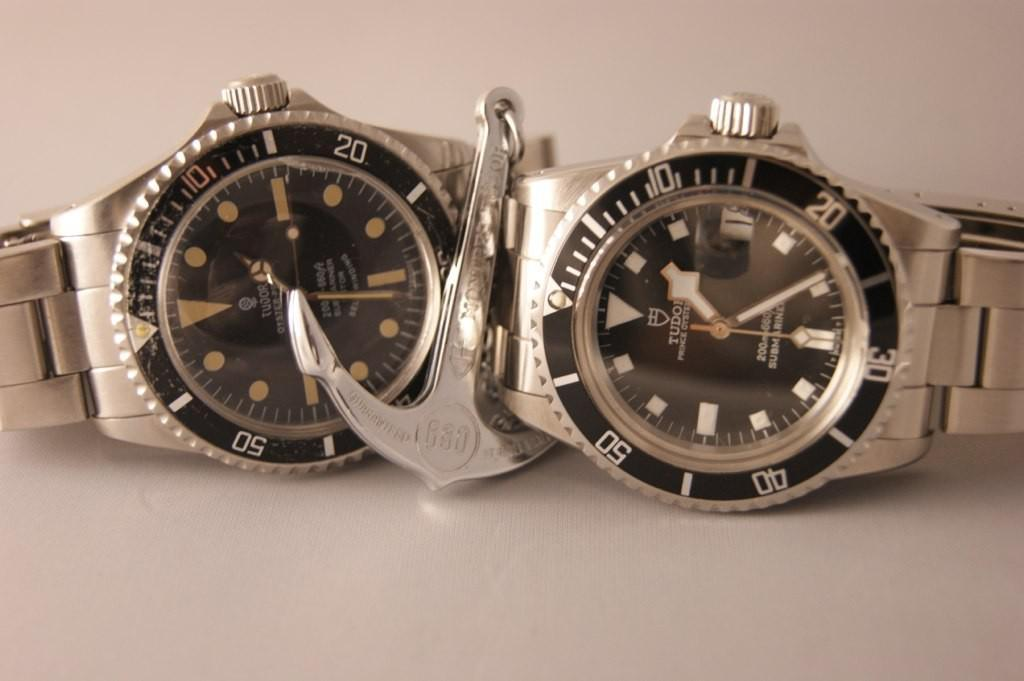<image>
Offer a succinct explanation of the picture presented. Two Tudor watches lay by one another, a silver anchor between them.. 